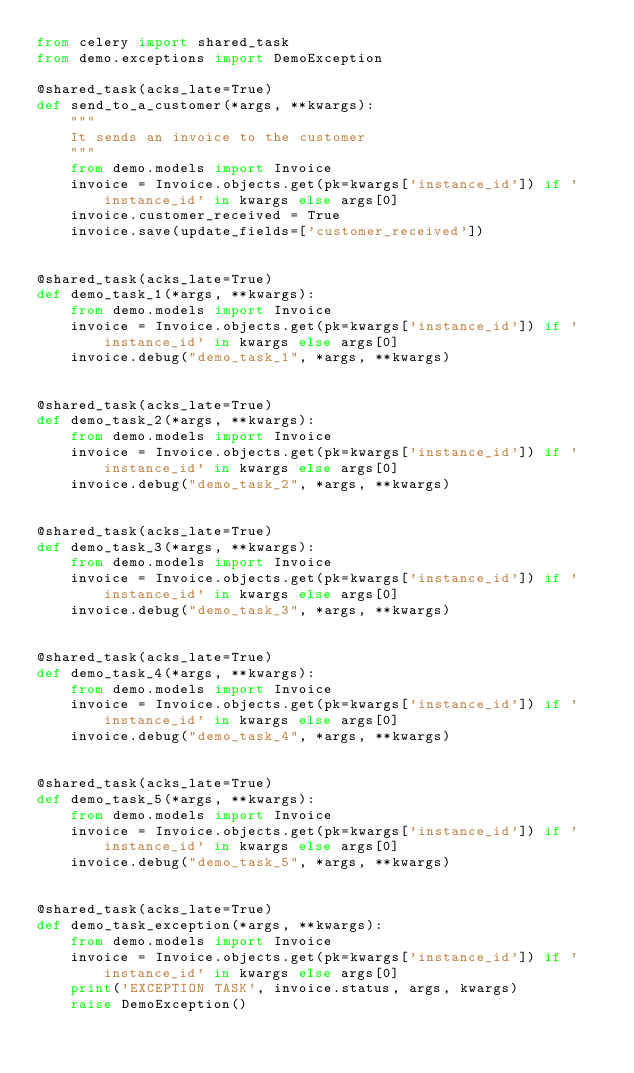Convert code to text. <code><loc_0><loc_0><loc_500><loc_500><_Python_>from celery import shared_task
from demo.exceptions import DemoException

@shared_task(acks_late=True)
def send_to_a_customer(*args, **kwargs):
    """
    It sends an invoice to the customer
    """
    from demo.models import Invoice
    invoice = Invoice.objects.get(pk=kwargs['instance_id']) if 'instance_id' in kwargs else args[0]
    invoice.customer_received = True
    invoice.save(update_fields=['customer_received'])


@shared_task(acks_late=True)
def demo_task_1(*args, **kwargs):
    from demo.models import Invoice
    invoice = Invoice.objects.get(pk=kwargs['instance_id']) if 'instance_id' in kwargs else args[0]
    invoice.debug("demo_task_1", *args, **kwargs)


@shared_task(acks_late=True)
def demo_task_2(*args, **kwargs):
    from demo.models import Invoice
    invoice = Invoice.objects.get(pk=kwargs['instance_id']) if 'instance_id' in kwargs else args[0]
    invoice.debug("demo_task_2", *args, **kwargs)


@shared_task(acks_late=True)
def demo_task_3(*args, **kwargs):
    from demo.models import Invoice
    invoice = Invoice.objects.get(pk=kwargs['instance_id']) if 'instance_id' in kwargs else args[0]
    invoice.debug("demo_task_3", *args, **kwargs)


@shared_task(acks_late=True)
def demo_task_4(*args, **kwargs):
    from demo.models import Invoice
    invoice = Invoice.objects.get(pk=kwargs['instance_id']) if 'instance_id' in kwargs else args[0]
    invoice.debug("demo_task_4", *args, **kwargs)


@shared_task(acks_late=True)
def demo_task_5(*args, **kwargs):
    from demo.models import Invoice
    invoice = Invoice.objects.get(pk=kwargs['instance_id']) if 'instance_id' in kwargs else args[0]
    invoice.debug("demo_task_5", *args, **kwargs)


@shared_task(acks_late=True)
def demo_task_exception(*args, **kwargs):
    from demo.models import Invoice
    invoice = Invoice.objects.get(pk=kwargs['instance_id']) if 'instance_id' in kwargs else args[0]
    print('EXCEPTION TASK', invoice.status, args, kwargs)
    raise DemoException()
</code> 